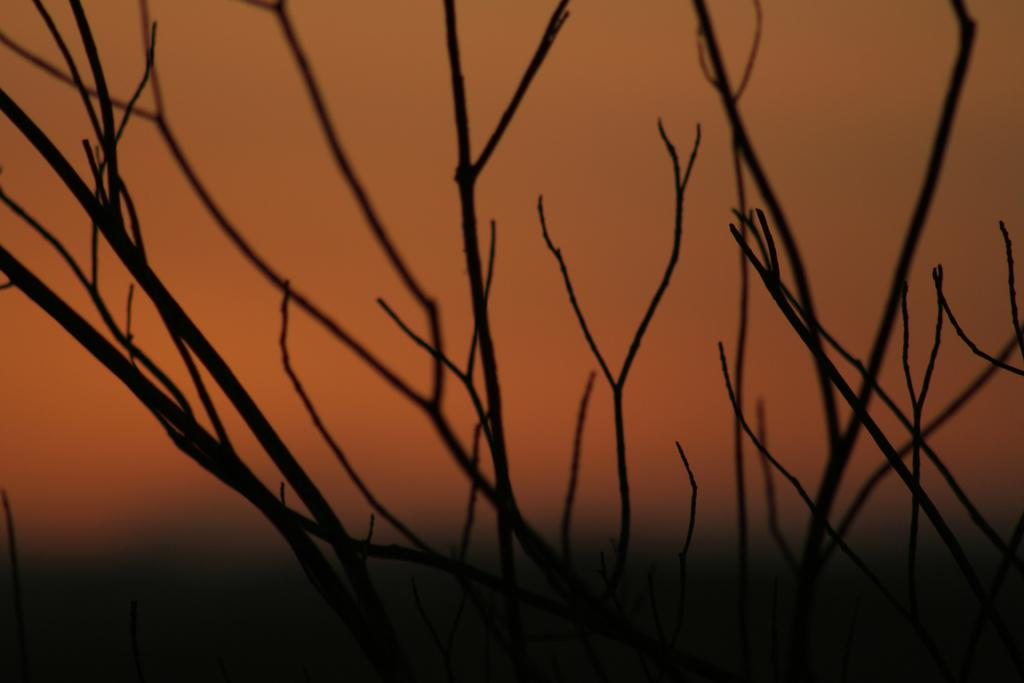What is the main subject of the image? The main subject of the image is the branches of a tree. What can be seen in the background of the image? The background of the image appears orange in color. Can you see a chicken wearing a crown in the image? No, there is no chicken or crown present in the image. How many stitches are visible on the branches of the tree in the image? There are no stitches on the branches of the tree in the image, as stitches are typically associated with fabric or sewing, not tree branches. 